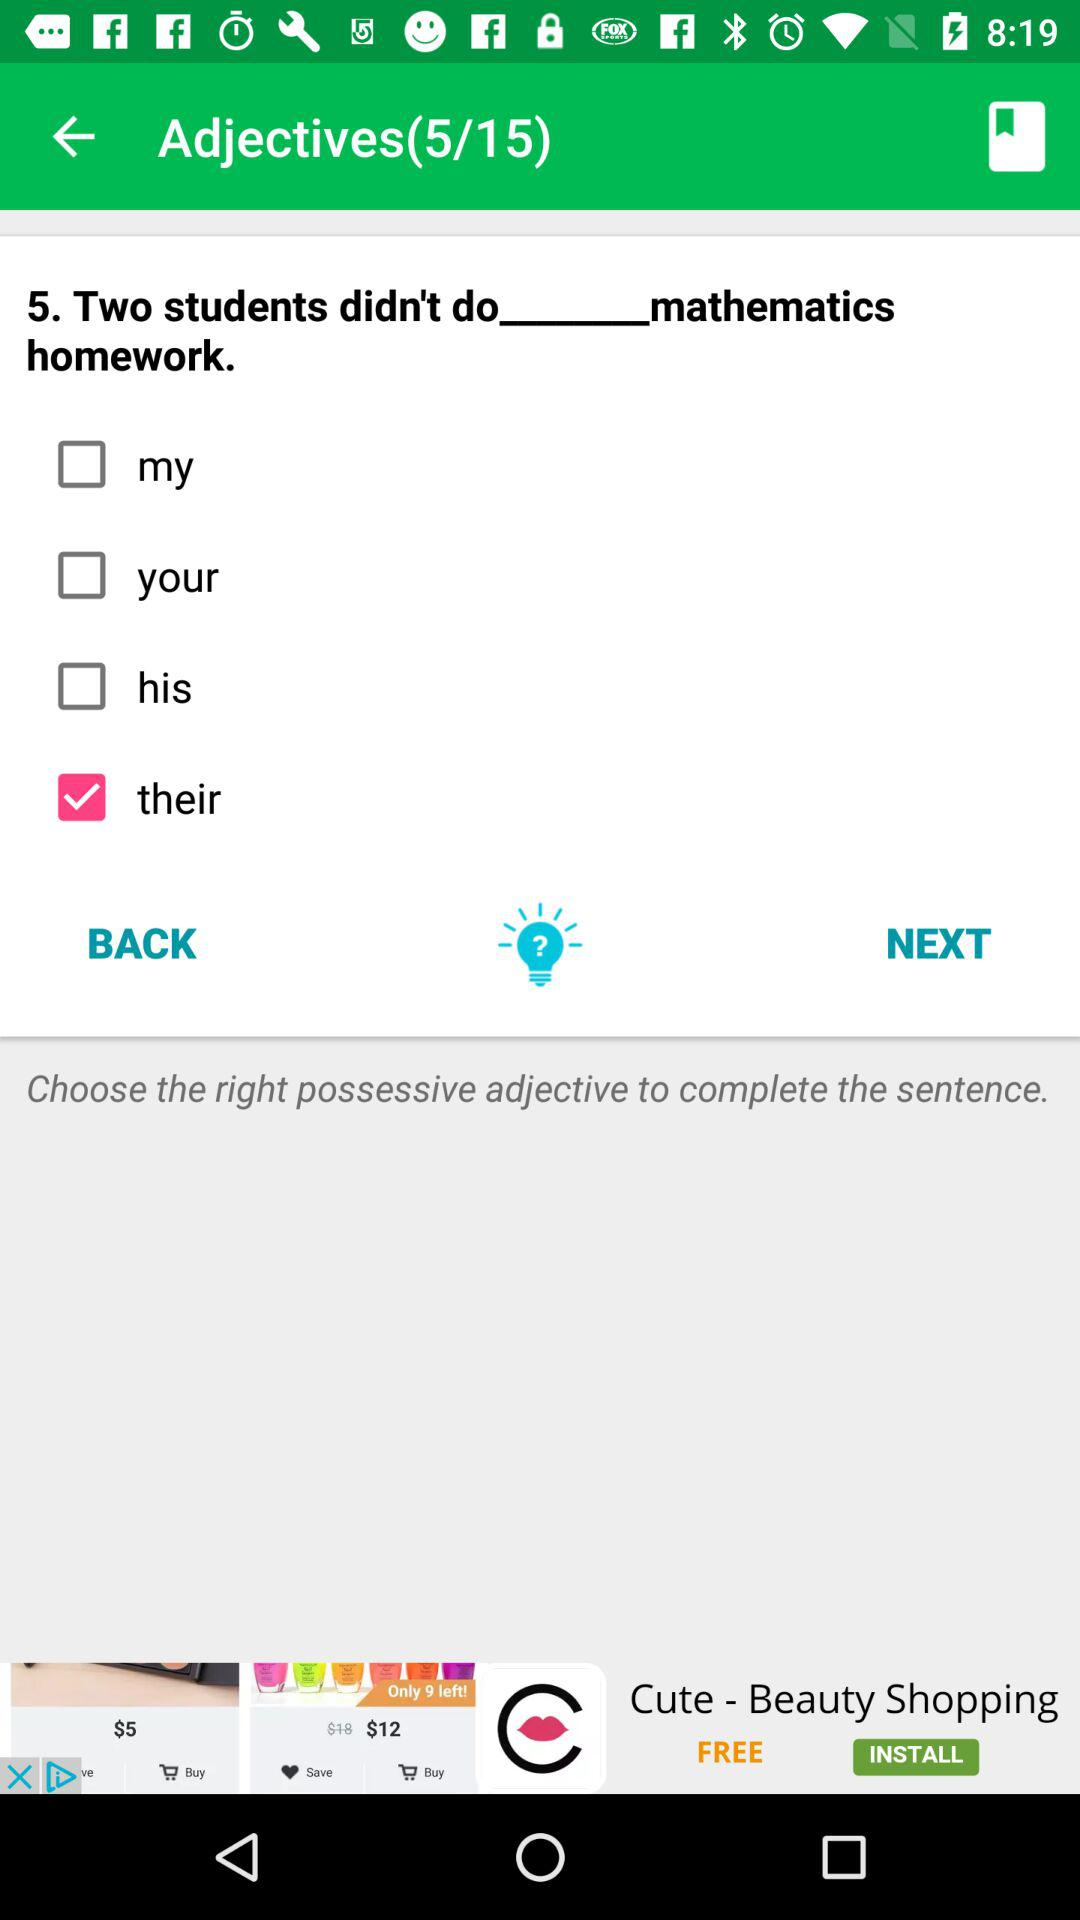Why is 'their' the correct answer in this case? The word 'their' is the correct answer because the sentence refers to 'two students,' which is plural. 'Their' is the plural possessive adjective that corresponds to this plural subject, indicating that the mathematics homework belongs to both students.  What would be incorrect about choosing 'his' or 'my' in this sentence? 'His' would be incorrect because it is a singular possessive adjective and assumes that the homework belongs to only one male student, which does not align with 'two students.' 'My' suggests that the speaker owns the homework, which does not match the third-person perspective in 'two students.' 